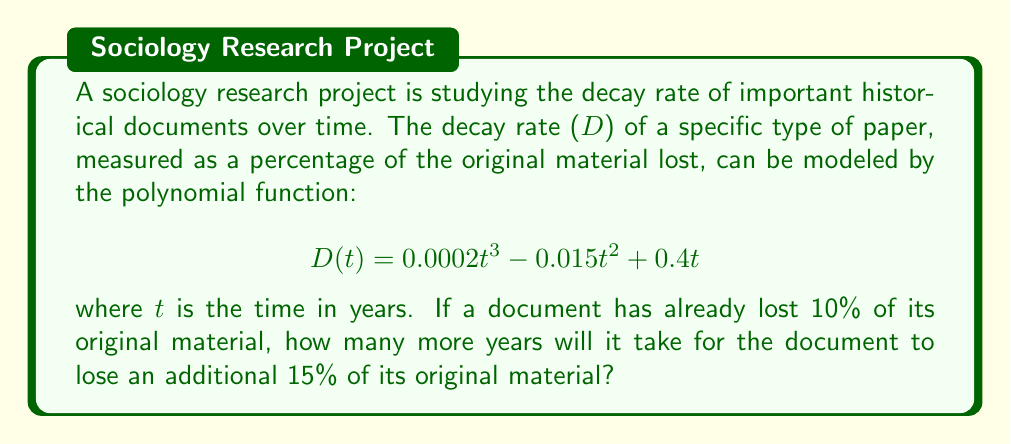Can you solve this math problem? 1) First, we need to find the time t when the document has lost 10% of its material:
   $$0.0002t^3 - 0.015t^2 + 0.4t = 10$$

2) This is a cubic equation that's difficult to solve analytically. Using numerical methods or a graphing calculator, we find that t ≈ 27.76 years.

3) Now, we need to find when the document will have lost 25% (10% + 15%) of its material:
   $$0.0002t^3 - 0.015t^2 + 0.4t = 25$$

4) Solving this equation numerically, we get t ≈ 71.23 years.

5) The difference between these two times is:
   71.23 - 27.76 = 43.47 years

6) Rounding to the nearest year, it will take approximately 43 more years for the document to lose an additional 15% of its original material.
Answer: 43 years 